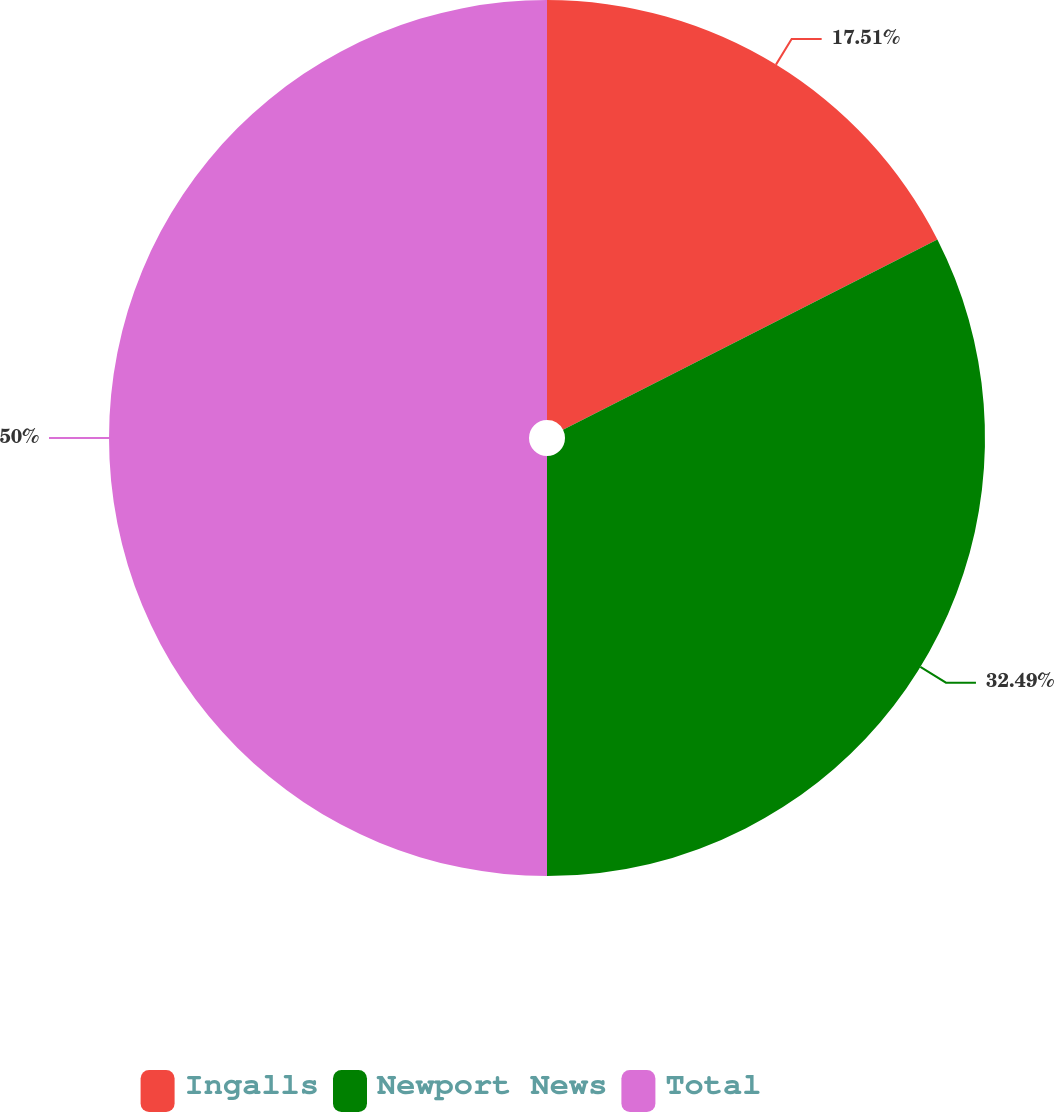Convert chart. <chart><loc_0><loc_0><loc_500><loc_500><pie_chart><fcel>Ingalls<fcel>Newport News<fcel>Total<nl><fcel>17.51%<fcel>32.49%<fcel>50.0%<nl></chart> 